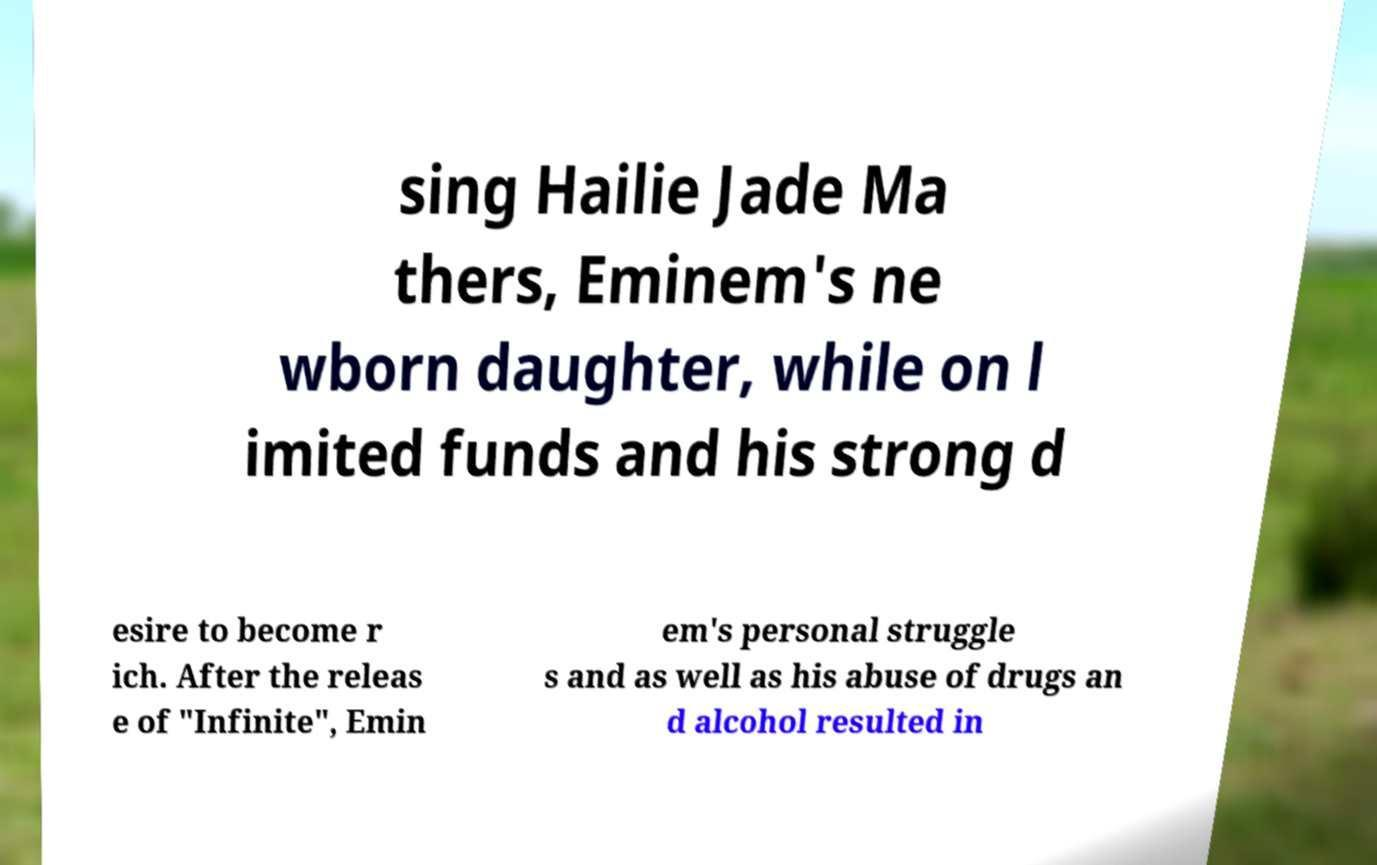For documentation purposes, I need the text within this image transcribed. Could you provide that? sing Hailie Jade Ma thers, Eminem's ne wborn daughter, while on l imited funds and his strong d esire to become r ich. After the releas e of "Infinite", Emin em's personal struggle s and as well as his abuse of drugs an d alcohol resulted in 